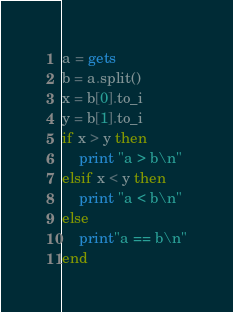<code> <loc_0><loc_0><loc_500><loc_500><_Ruby_>a = gets
b = a.split()
x = b[0].to_i
y = b[1].to_i
if x > y then
	print "a > b\n"
elsif x < y then
	print "a < b\n"
else
	print"a == b\n"
end</code> 